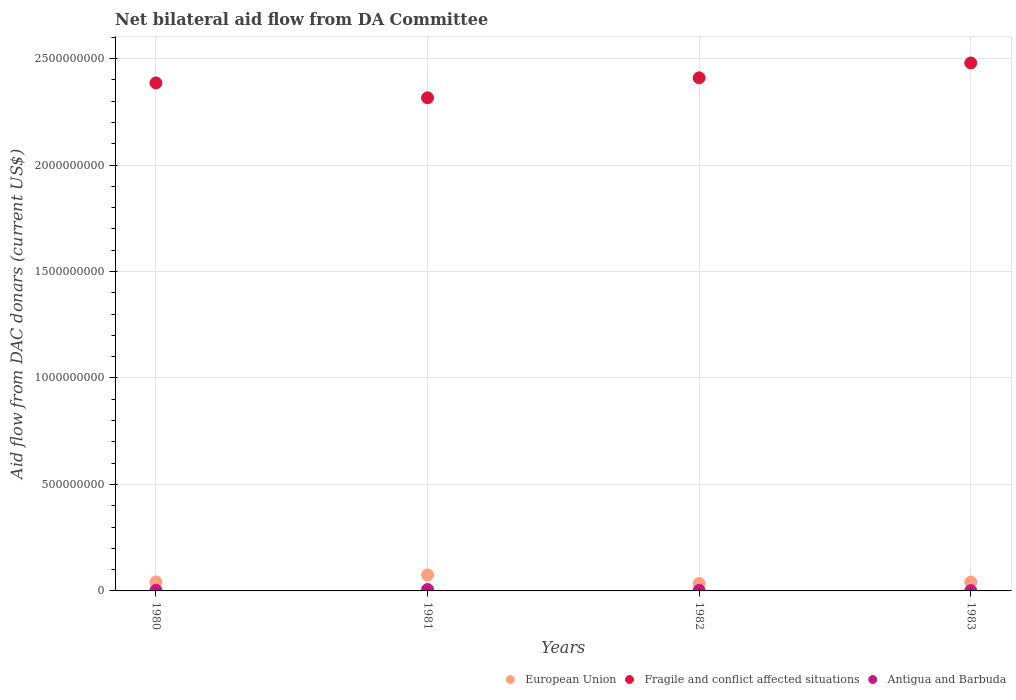How many different coloured dotlines are there?
Your response must be concise. 3. Is the number of dotlines equal to the number of legend labels?
Make the answer very short. Yes. What is the aid flow in in European Union in 1980?
Provide a short and direct response. 4.24e+07. Across all years, what is the maximum aid flow in in Fragile and conflict affected situations?
Your answer should be very brief. 2.48e+09. Across all years, what is the minimum aid flow in in Antigua and Barbuda?
Provide a succinct answer. 1.41e+06. What is the total aid flow in in Antigua and Barbuda in the graph?
Offer a terse response. 1.30e+07. What is the difference between the aid flow in in Fragile and conflict affected situations in 1980 and that in 1983?
Provide a short and direct response. -9.38e+07. What is the difference between the aid flow in in Antigua and Barbuda in 1983 and the aid flow in in European Union in 1981?
Provide a succinct answer. -7.37e+07. What is the average aid flow in in Fragile and conflict affected situations per year?
Offer a terse response. 2.40e+09. In the year 1981, what is the difference between the aid flow in in Fragile and conflict affected situations and aid flow in in European Union?
Your response must be concise. 2.24e+09. What is the ratio of the aid flow in in Antigua and Barbuda in 1980 to that in 1981?
Provide a succinct answer. 0.39. Is the aid flow in in European Union in 1981 less than that in 1982?
Provide a succinct answer. No. What is the difference between the highest and the second highest aid flow in in European Union?
Provide a short and direct response. 3.27e+07. What is the difference between the highest and the lowest aid flow in in Antigua and Barbuda?
Provide a succinct answer. 5.25e+06. In how many years, is the aid flow in in European Union greater than the average aid flow in in European Union taken over all years?
Your answer should be compact. 1. Is it the case that in every year, the sum of the aid flow in in European Union and aid flow in in Antigua and Barbuda  is greater than the aid flow in in Fragile and conflict affected situations?
Keep it short and to the point. No. Is the aid flow in in Antigua and Barbuda strictly less than the aid flow in in European Union over the years?
Make the answer very short. Yes. How many dotlines are there?
Your answer should be compact. 3. How many years are there in the graph?
Provide a succinct answer. 4. Where does the legend appear in the graph?
Give a very brief answer. Bottom right. How are the legend labels stacked?
Your answer should be compact. Horizontal. What is the title of the graph?
Provide a short and direct response. Net bilateral aid flow from DA Committee. Does "East Asia (developing only)" appear as one of the legend labels in the graph?
Offer a terse response. No. What is the label or title of the Y-axis?
Ensure brevity in your answer.  Aid flow from DAC donars (current US$). What is the Aid flow from DAC donars (current US$) in European Union in 1980?
Ensure brevity in your answer.  4.24e+07. What is the Aid flow from DAC donars (current US$) in Fragile and conflict affected situations in 1980?
Your answer should be very brief. 2.39e+09. What is the Aid flow from DAC donars (current US$) of Antigua and Barbuda in 1980?
Provide a succinct answer. 2.59e+06. What is the Aid flow from DAC donars (current US$) of European Union in 1981?
Keep it short and to the point. 7.51e+07. What is the Aid flow from DAC donars (current US$) in Fragile and conflict affected situations in 1981?
Your answer should be compact. 2.32e+09. What is the Aid flow from DAC donars (current US$) of Antigua and Barbuda in 1981?
Provide a succinct answer. 6.66e+06. What is the Aid flow from DAC donars (current US$) in European Union in 1982?
Your answer should be compact. 3.48e+07. What is the Aid flow from DAC donars (current US$) of Fragile and conflict affected situations in 1982?
Your response must be concise. 2.41e+09. What is the Aid flow from DAC donars (current US$) of Antigua and Barbuda in 1982?
Offer a terse response. 2.31e+06. What is the Aid flow from DAC donars (current US$) of European Union in 1983?
Provide a short and direct response. 4.15e+07. What is the Aid flow from DAC donars (current US$) in Fragile and conflict affected situations in 1983?
Keep it short and to the point. 2.48e+09. What is the Aid flow from DAC donars (current US$) of Antigua and Barbuda in 1983?
Offer a terse response. 1.41e+06. Across all years, what is the maximum Aid flow from DAC donars (current US$) in European Union?
Offer a very short reply. 7.51e+07. Across all years, what is the maximum Aid flow from DAC donars (current US$) in Fragile and conflict affected situations?
Provide a succinct answer. 2.48e+09. Across all years, what is the maximum Aid flow from DAC donars (current US$) in Antigua and Barbuda?
Make the answer very short. 6.66e+06. Across all years, what is the minimum Aid flow from DAC donars (current US$) of European Union?
Give a very brief answer. 3.48e+07. Across all years, what is the minimum Aid flow from DAC donars (current US$) of Fragile and conflict affected situations?
Make the answer very short. 2.32e+09. Across all years, what is the minimum Aid flow from DAC donars (current US$) of Antigua and Barbuda?
Offer a terse response. 1.41e+06. What is the total Aid flow from DAC donars (current US$) in European Union in the graph?
Give a very brief answer. 1.94e+08. What is the total Aid flow from DAC donars (current US$) of Fragile and conflict affected situations in the graph?
Ensure brevity in your answer.  9.59e+09. What is the total Aid flow from DAC donars (current US$) of Antigua and Barbuda in the graph?
Ensure brevity in your answer.  1.30e+07. What is the difference between the Aid flow from DAC donars (current US$) in European Union in 1980 and that in 1981?
Offer a very short reply. -3.27e+07. What is the difference between the Aid flow from DAC donars (current US$) in Fragile and conflict affected situations in 1980 and that in 1981?
Your response must be concise. 6.99e+07. What is the difference between the Aid flow from DAC donars (current US$) in Antigua and Barbuda in 1980 and that in 1981?
Provide a succinct answer. -4.07e+06. What is the difference between the Aid flow from DAC donars (current US$) of European Union in 1980 and that in 1982?
Keep it short and to the point. 7.58e+06. What is the difference between the Aid flow from DAC donars (current US$) of Fragile and conflict affected situations in 1980 and that in 1982?
Your response must be concise. -2.40e+07. What is the difference between the Aid flow from DAC donars (current US$) of European Union in 1980 and that in 1983?
Offer a terse response. 8.40e+05. What is the difference between the Aid flow from DAC donars (current US$) in Fragile and conflict affected situations in 1980 and that in 1983?
Offer a very short reply. -9.38e+07. What is the difference between the Aid flow from DAC donars (current US$) of Antigua and Barbuda in 1980 and that in 1983?
Give a very brief answer. 1.18e+06. What is the difference between the Aid flow from DAC donars (current US$) in European Union in 1981 and that in 1982?
Provide a short and direct response. 4.03e+07. What is the difference between the Aid flow from DAC donars (current US$) of Fragile and conflict affected situations in 1981 and that in 1982?
Ensure brevity in your answer.  -9.38e+07. What is the difference between the Aid flow from DAC donars (current US$) of Antigua and Barbuda in 1981 and that in 1982?
Your answer should be very brief. 4.35e+06. What is the difference between the Aid flow from DAC donars (current US$) in European Union in 1981 and that in 1983?
Your response must be concise. 3.36e+07. What is the difference between the Aid flow from DAC donars (current US$) in Fragile and conflict affected situations in 1981 and that in 1983?
Your answer should be compact. -1.64e+08. What is the difference between the Aid flow from DAC donars (current US$) in Antigua and Barbuda in 1981 and that in 1983?
Your answer should be very brief. 5.25e+06. What is the difference between the Aid flow from DAC donars (current US$) of European Union in 1982 and that in 1983?
Offer a very short reply. -6.74e+06. What is the difference between the Aid flow from DAC donars (current US$) of Fragile and conflict affected situations in 1982 and that in 1983?
Provide a succinct answer. -6.98e+07. What is the difference between the Aid flow from DAC donars (current US$) in European Union in 1980 and the Aid flow from DAC donars (current US$) in Fragile and conflict affected situations in 1981?
Your answer should be very brief. -2.27e+09. What is the difference between the Aid flow from DAC donars (current US$) in European Union in 1980 and the Aid flow from DAC donars (current US$) in Antigua and Barbuda in 1981?
Give a very brief answer. 3.57e+07. What is the difference between the Aid flow from DAC donars (current US$) in Fragile and conflict affected situations in 1980 and the Aid flow from DAC donars (current US$) in Antigua and Barbuda in 1981?
Make the answer very short. 2.38e+09. What is the difference between the Aid flow from DAC donars (current US$) of European Union in 1980 and the Aid flow from DAC donars (current US$) of Fragile and conflict affected situations in 1982?
Ensure brevity in your answer.  -2.37e+09. What is the difference between the Aid flow from DAC donars (current US$) in European Union in 1980 and the Aid flow from DAC donars (current US$) in Antigua and Barbuda in 1982?
Make the answer very short. 4.00e+07. What is the difference between the Aid flow from DAC donars (current US$) in Fragile and conflict affected situations in 1980 and the Aid flow from DAC donars (current US$) in Antigua and Barbuda in 1982?
Offer a very short reply. 2.38e+09. What is the difference between the Aid flow from DAC donars (current US$) of European Union in 1980 and the Aid flow from DAC donars (current US$) of Fragile and conflict affected situations in 1983?
Give a very brief answer. -2.44e+09. What is the difference between the Aid flow from DAC donars (current US$) in European Union in 1980 and the Aid flow from DAC donars (current US$) in Antigua and Barbuda in 1983?
Make the answer very short. 4.09e+07. What is the difference between the Aid flow from DAC donars (current US$) of Fragile and conflict affected situations in 1980 and the Aid flow from DAC donars (current US$) of Antigua and Barbuda in 1983?
Make the answer very short. 2.38e+09. What is the difference between the Aid flow from DAC donars (current US$) in European Union in 1981 and the Aid flow from DAC donars (current US$) in Fragile and conflict affected situations in 1982?
Offer a terse response. -2.33e+09. What is the difference between the Aid flow from DAC donars (current US$) of European Union in 1981 and the Aid flow from DAC donars (current US$) of Antigua and Barbuda in 1982?
Provide a succinct answer. 7.28e+07. What is the difference between the Aid flow from DAC donars (current US$) in Fragile and conflict affected situations in 1981 and the Aid flow from DAC donars (current US$) in Antigua and Barbuda in 1982?
Your response must be concise. 2.31e+09. What is the difference between the Aid flow from DAC donars (current US$) in European Union in 1981 and the Aid flow from DAC donars (current US$) in Fragile and conflict affected situations in 1983?
Your response must be concise. -2.40e+09. What is the difference between the Aid flow from DAC donars (current US$) of European Union in 1981 and the Aid flow from DAC donars (current US$) of Antigua and Barbuda in 1983?
Your answer should be very brief. 7.37e+07. What is the difference between the Aid flow from DAC donars (current US$) of Fragile and conflict affected situations in 1981 and the Aid flow from DAC donars (current US$) of Antigua and Barbuda in 1983?
Give a very brief answer. 2.31e+09. What is the difference between the Aid flow from DAC donars (current US$) in European Union in 1982 and the Aid flow from DAC donars (current US$) in Fragile and conflict affected situations in 1983?
Ensure brevity in your answer.  -2.44e+09. What is the difference between the Aid flow from DAC donars (current US$) in European Union in 1982 and the Aid flow from DAC donars (current US$) in Antigua and Barbuda in 1983?
Provide a succinct answer. 3.34e+07. What is the difference between the Aid flow from DAC donars (current US$) in Fragile and conflict affected situations in 1982 and the Aid flow from DAC donars (current US$) in Antigua and Barbuda in 1983?
Your answer should be very brief. 2.41e+09. What is the average Aid flow from DAC donars (current US$) in European Union per year?
Offer a terse response. 4.84e+07. What is the average Aid flow from DAC donars (current US$) in Fragile and conflict affected situations per year?
Provide a short and direct response. 2.40e+09. What is the average Aid flow from DAC donars (current US$) of Antigua and Barbuda per year?
Offer a terse response. 3.24e+06. In the year 1980, what is the difference between the Aid flow from DAC donars (current US$) of European Union and Aid flow from DAC donars (current US$) of Fragile and conflict affected situations?
Offer a very short reply. -2.34e+09. In the year 1980, what is the difference between the Aid flow from DAC donars (current US$) of European Union and Aid flow from DAC donars (current US$) of Antigua and Barbuda?
Your response must be concise. 3.98e+07. In the year 1980, what is the difference between the Aid flow from DAC donars (current US$) in Fragile and conflict affected situations and Aid flow from DAC donars (current US$) in Antigua and Barbuda?
Keep it short and to the point. 2.38e+09. In the year 1981, what is the difference between the Aid flow from DAC donars (current US$) of European Union and Aid flow from DAC donars (current US$) of Fragile and conflict affected situations?
Provide a short and direct response. -2.24e+09. In the year 1981, what is the difference between the Aid flow from DAC donars (current US$) of European Union and Aid flow from DAC donars (current US$) of Antigua and Barbuda?
Your answer should be very brief. 6.84e+07. In the year 1981, what is the difference between the Aid flow from DAC donars (current US$) of Fragile and conflict affected situations and Aid flow from DAC donars (current US$) of Antigua and Barbuda?
Offer a very short reply. 2.31e+09. In the year 1982, what is the difference between the Aid flow from DAC donars (current US$) in European Union and Aid flow from DAC donars (current US$) in Fragile and conflict affected situations?
Offer a terse response. -2.37e+09. In the year 1982, what is the difference between the Aid flow from DAC donars (current US$) of European Union and Aid flow from DAC donars (current US$) of Antigua and Barbuda?
Your answer should be very brief. 3.25e+07. In the year 1982, what is the difference between the Aid flow from DAC donars (current US$) of Fragile and conflict affected situations and Aid flow from DAC donars (current US$) of Antigua and Barbuda?
Offer a very short reply. 2.41e+09. In the year 1983, what is the difference between the Aid flow from DAC donars (current US$) of European Union and Aid flow from DAC donars (current US$) of Fragile and conflict affected situations?
Provide a succinct answer. -2.44e+09. In the year 1983, what is the difference between the Aid flow from DAC donars (current US$) in European Union and Aid flow from DAC donars (current US$) in Antigua and Barbuda?
Ensure brevity in your answer.  4.01e+07. In the year 1983, what is the difference between the Aid flow from DAC donars (current US$) of Fragile and conflict affected situations and Aid flow from DAC donars (current US$) of Antigua and Barbuda?
Provide a short and direct response. 2.48e+09. What is the ratio of the Aid flow from DAC donars (current US$) of European Union in 1980 to that in 1981?
Offer a terse response. 0.56. What is the ratio of the Aid flow from DAC donars (current US$) in Fragile and conflict affected situations in 1980 to that in 1981?
Provide a short and direct response. 1.03. What is the ratio of the Aid flow from DAC donars (current US$) in Antigua and Barbuda in 1980 to that in 1981?
Make the answer very short. 0.39. What is the ratio of the Aid flow from DAC donars (current US$) of European Union in 1980 to that in 1982?
Offer a very short reply. 1.22. What is the ratio of the Aid flow from DAC donars (current US$) of Antigua and Barbuda in 1980 to that in 1982?
Your answer should be compact. 1.12. What is the ratio of the Aid flow from DAC donars (current US$) in European Union in 1980 to that in 1983?
Make the answer very short. 1.02. What is the ratio of the Aid flow from DAC donars (current US$) in Fragile and conflict affected situations in 1980 to that in 1983?
Provide a succinct answer. 0.96. What is the ratio of the Aid flow from DAC donars (current US$) of Antigua and Barbuda in 1980 to that in 1983?
Make the answer very short. 1.84. What is the ratio of the Aid flow from DAC donars (current US$) in European Union in 1981 to that in 1982?
Offer a terse response. 2.16. What is the ratio of the Aid flow from DAC donars (current US$) of Fragile and conflict affected situations in 1981 to that in 1982?
Ensure brevity in your answer.  0.96. What is the ratio of the Aid flow from DAC donars (current US$) in Antigua and Barbuda in 1981 to that in 1982?
Provide a succinct answer. 2.88. What is the ratio of the Aid flow from DAC donars (current US$) of European Union in 1981 to that in 1983?
Your answer should be very brief. 1.81. What is the ratio of the Aid flow from DAC donars (current US$) in Fragile and conflict affected situations in 1981 to that in 1983?
Make the answer very short. 0.93. What is the ratio of the Aid flow from DAC donars (current US$) of Antigua and Barbuda in 1981 to that in 1983?
Your answer should be very brief. 4.72. What is the ratio of the Aid flow from DAC donars (current US$) in European Union in 1982 to that in 1983?
Your response must be concise. 0.84. What is the ratio of the Aid flow from DAC donars (current US$) of Fragile and conflict affected situations in 1982 to that in 1983?
Your response must be concise. 0.97. What is the ratio of the Aid flow from DAC donars (current US$) of Antigua and Barbuda in 1982 to that in 1983?
Make the answer very short. 1.64. What is the difference between the highest and the second highest Aid flow from DAC donars (current US$) of European Union?
Offer a very short reply. 3.27e+07. What is the difference between the highest and the second highest Aid flow from DAC donars (current US$) of Fragile and conflict affected situations?
Give a very brief answer. 6.98e+07. What is the difference between the highest and the second highest Aid flow from DAC donars (current US$) of Antigua and Barbuda?
Provide a short and direct response. 4.07e+06. What is the difference between the highest and the lowest Aid flow from DAC donars (current US$) in European Union?
Ensure brevity in your answer.  4.03e+07. What is the difference between the highest and the lowest Aid flow from DAC donars (current US$) in Fragile and conflict affected situations?
Offer a very short reply. 1.64e+08. What is the difference between the highest and the lowest Aid flow from DAC donars (current US$) of Antigua and Barbuda?
Provide a succinct answer. 5.25e+06. 